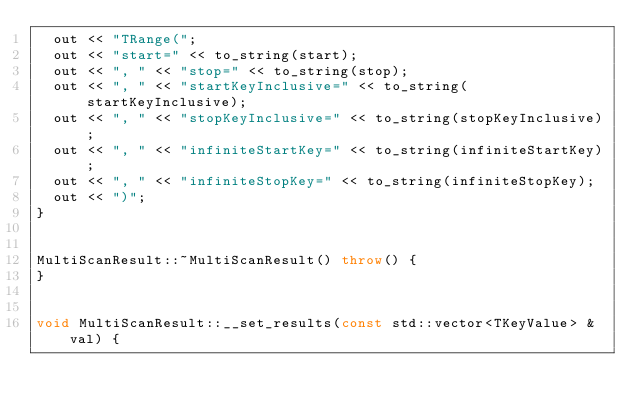Convert code to text. <code><loc_0><loc_0><loc_500><loc_500><_C++_>  out << "TRange(";
  out << "start=" << to_string(start);
  out << ", " << "stop=" << to_string(stop);
  out << ", " << "startKeyInclusive=" << to_string(startKeyInclusive);
  out << ", " << "stopKeyInclusive=" << to_string(stopKeyInclusive);
  out << ", " << "infiniteStartKey=" << to_string(infiniteStartKey);
  out << ", " << "infiniteStopKey=" << to_string(infiniteStopKey);
  out << ")";
}


MultiScanResult::~MultiScanResult() throw() {
}


void MultiScanResult::__set_results(const std::vector<TKeyValue> & val) {</code> 